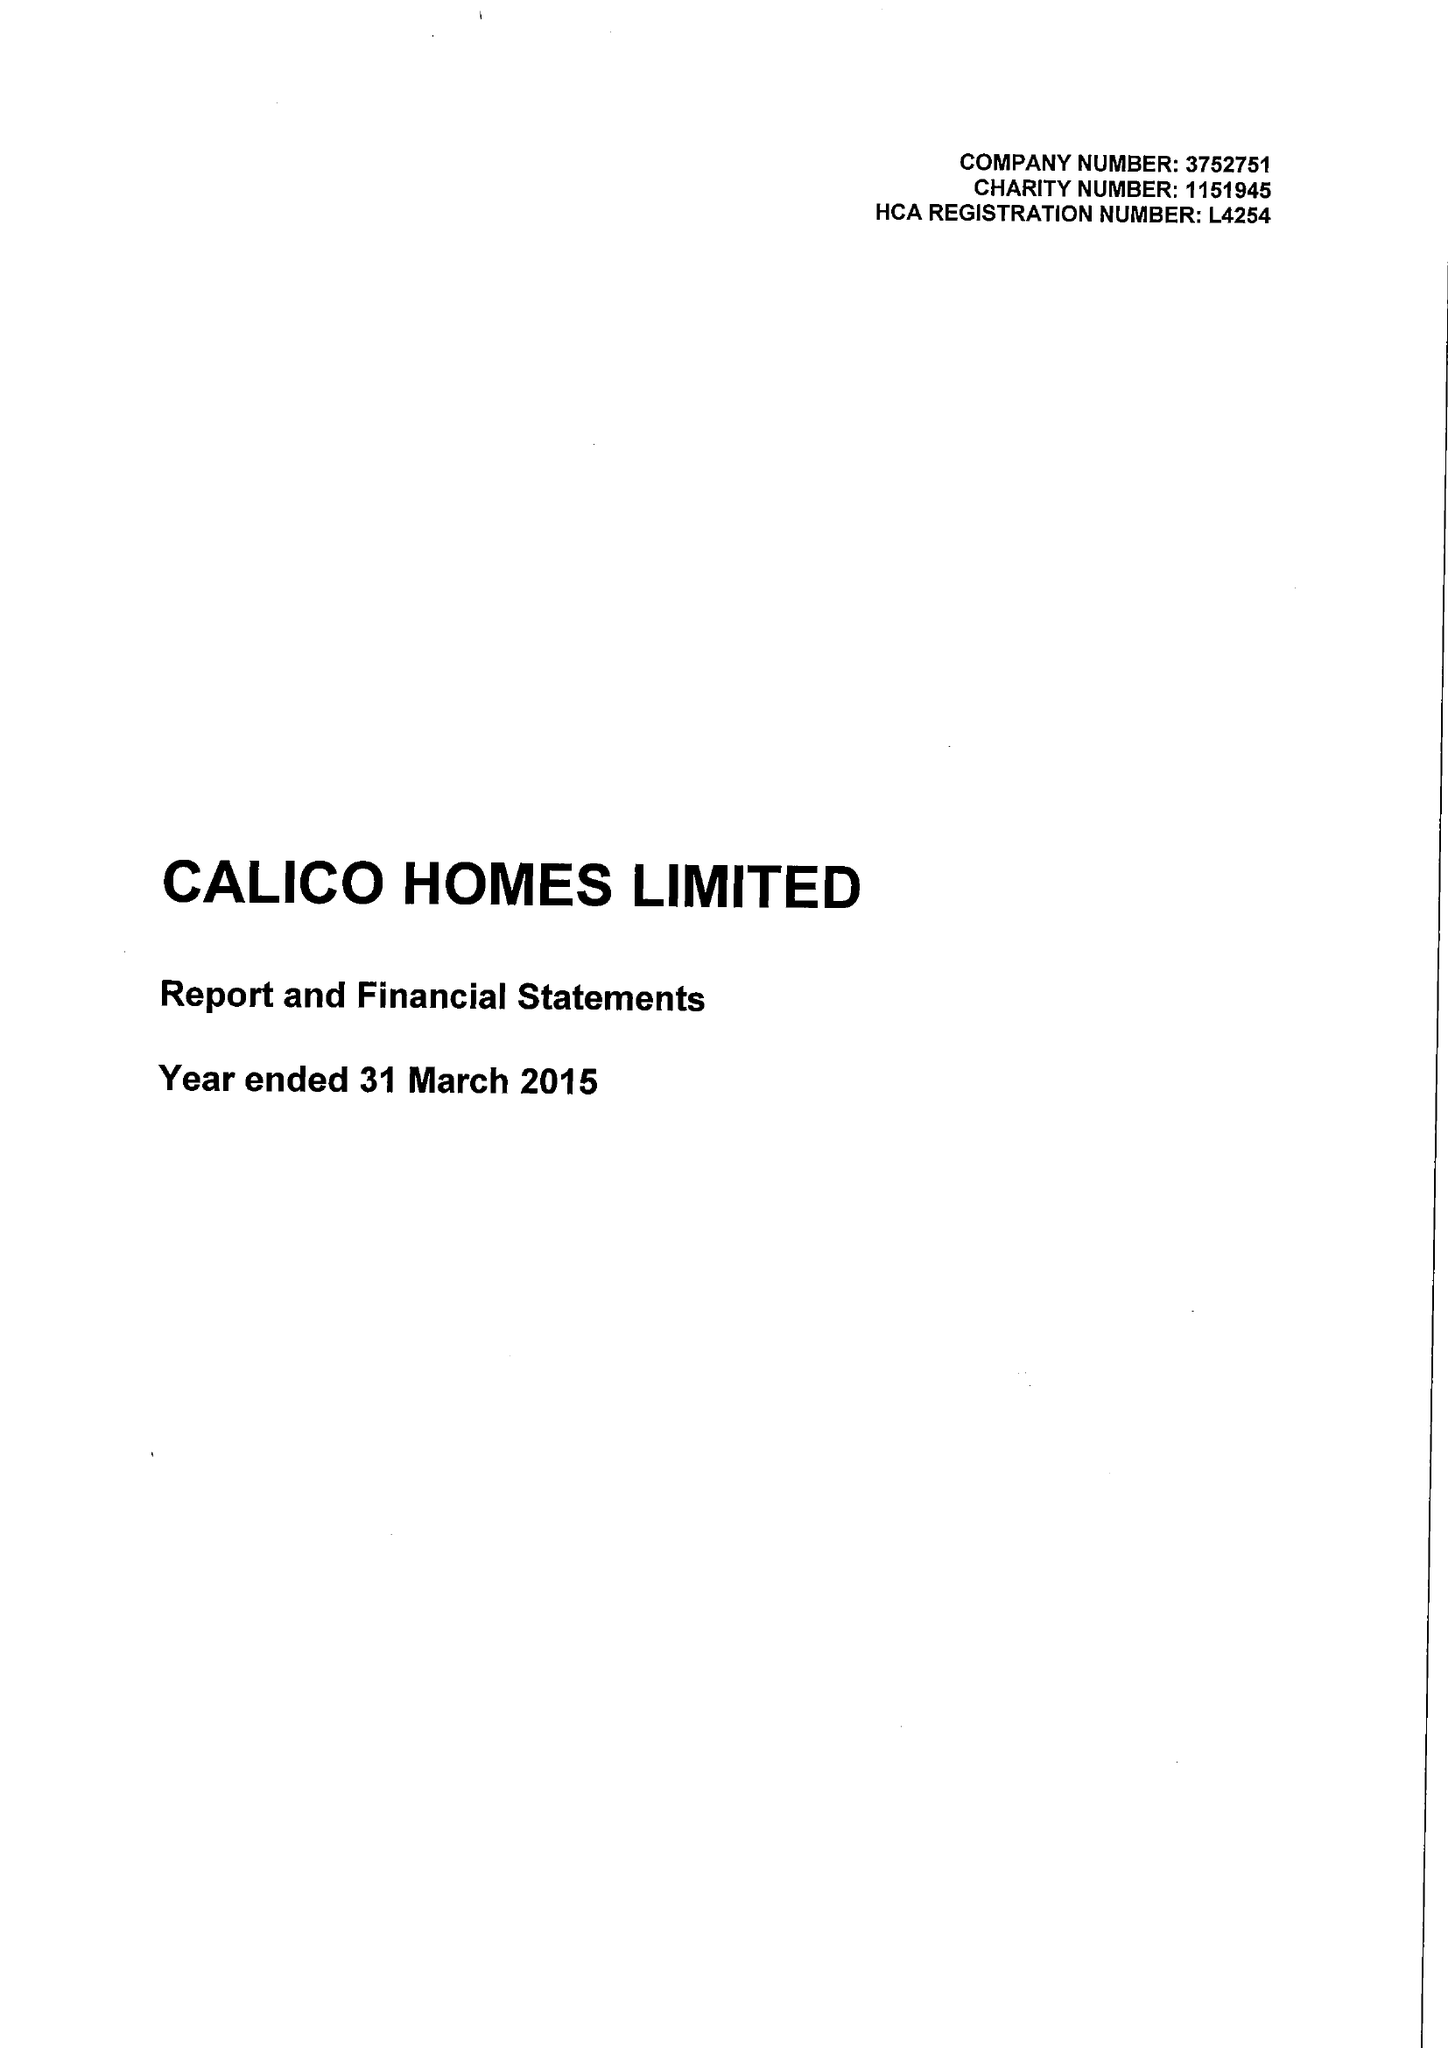What is the value for the address__post_town?
Answer the question using a single word or phrase. BURNLEY 